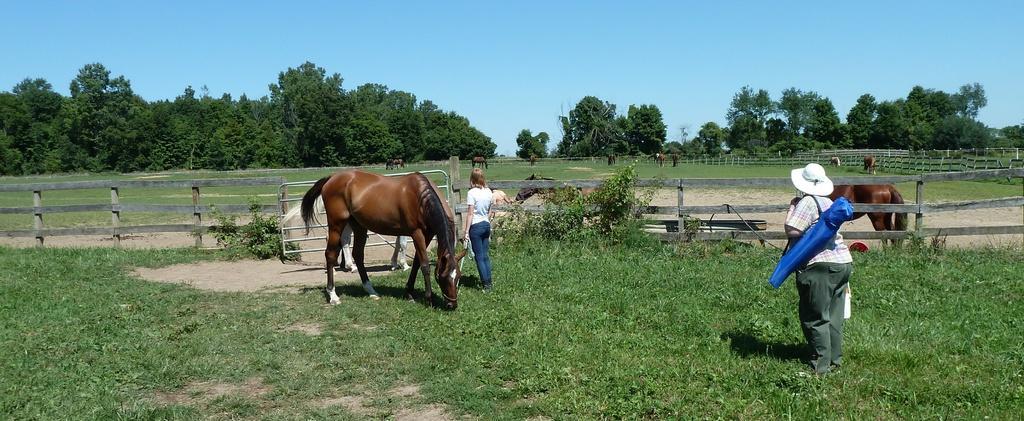How would you summarize this image in a sentence or two? Bottom of the image there is grass. In the middle of the image there are some horses and two persons are standing. Behind them there is a fencing. Top of the image there are some trees. Behind the trees there are some clouds and sky. 